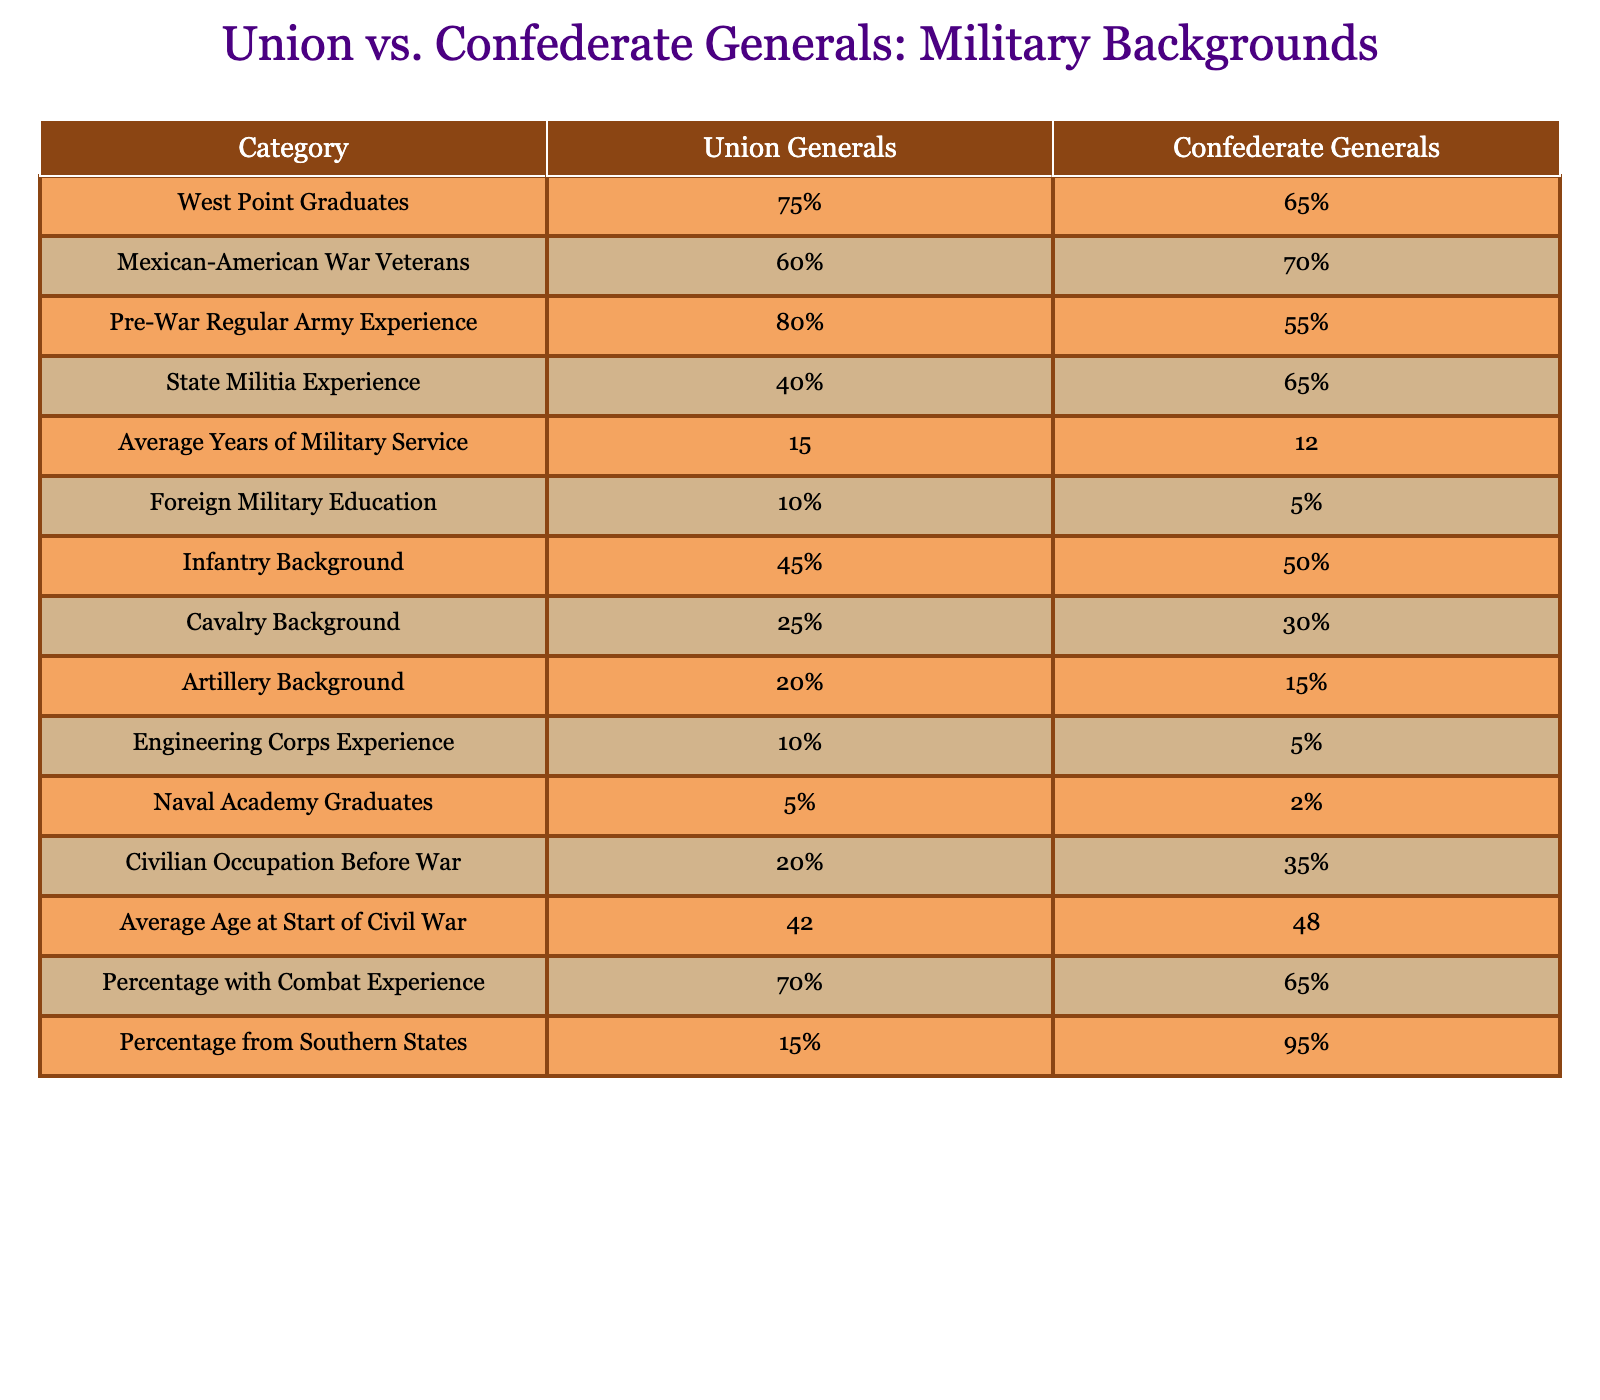What percentage of Union generals were West Point graduates? The table indicates that 75% of Union generals were West Point graduates, which is directly stated in the 'West Point Graduates' row under 'Union Generals'.
Answer: 75% How many Union generals had foreign military education compared to Confederate generals? According to the table, 10% of Union generals had foreign military education, whereas only 5% of Confederate generals did. To find the difference, we can calculate 10% - 5% = 5%.
Answer: 5% Is the average age of Union generals at the start of the Civil War younger than that of Confederate generals? The table shows that the average age of Union generals was 42, while Confederate generals were 48 years old. Since 42 is less than 48, Union generals were indeed younger.
Answer: Yes What is the difference in average years of military service between Union and Confederate generals? The table shows that Union generals had an average of 15 years of military service, while Confederate generals had 12 years. The difference can be calculated as 15 - 12 = 3 years.
Answer: 3 years What percentage of Confederate generals had pre-war regular army experience? Looking at the table, it is noted that 55% of Confederate generals had pre-war regular army experience, as stated in the 'Pre-War Regular Army Experience' row.
Answer: 55% If you combine the percentages of Union generals with infantry and artillery backgrounds, how does it compare to Confederate generals with the same backgrounds? The table indicates that 45% of Union generals had an infantry background and 20% had artillery experience, giving a combined total of 45% + 20% = 65%. For Confederate generals, 50% had an infantry background and 15% had artillery experience, totalling 50% + 15% = 65%. The two totals are equal: 65% for Union and 65% for Confederate.
Answer: Equal How many more Confederate generals had combat experience compared to Union generals? The table states that 70% of Union generals had combat experience and 65% of Confederate generals did. By calculating the difference, 70% - 65% = 5%, we find that Union generals had more combat experience by 5%.
Answer: 5% What is the percentage of Confederate generals from Southern states? The table specifies that 95% of Confederate generals came from Southern states, as indicated in that row.
Answer: 95% Which group had a higher percentage of veterans from the Mexican-American War, Union or Confederate generals? The table shows that 60% of Union generals were Mexican-American War veterans compared to 70% of Confederate generals. Since 70% is greater than 60%, Confederate generals had a higher percentage.
Answer: Confederate generals 